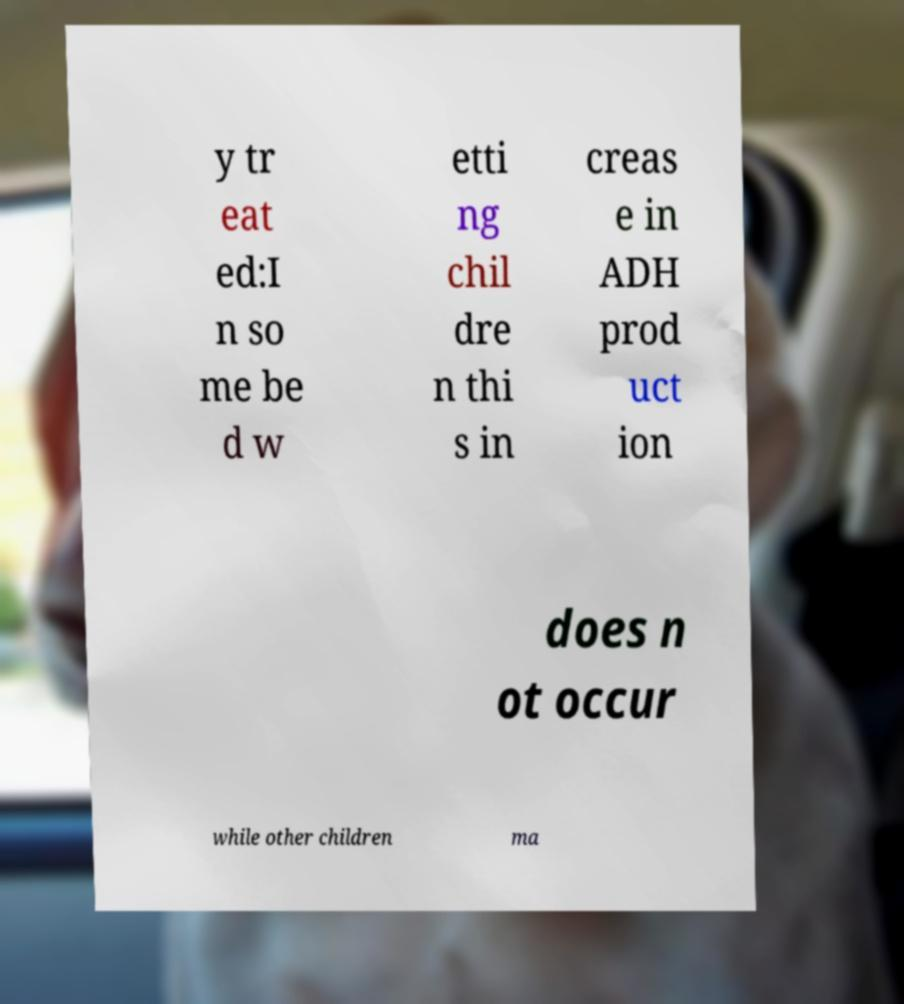Please identify and transcribe the text found in this image. y tr eat ed:I n so me be d w etti ng chil dre n thi s in creas e in ADH prod uct ion does n ot occur while other children ma 